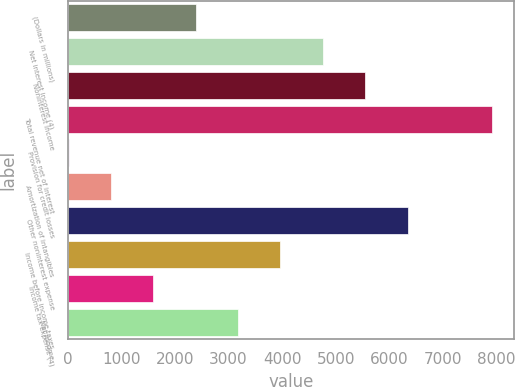Convert chart. <chart><loc_0><loc_0><loc_500><loc_500><bar_chart><fcel>(Dollars in millions)<fcel>Net interest income (4)<fcel>Noninterest income<fcel>Total revenue net of interest<fcel>Provision for credit losses<fcel>Amortization of intangibles<fcel>Other noninterest expense<fcel>Income before income taxes<fcel>Income tax expense (4)<fcel>Net income<nl><fcel>2386.7<fcel>4759.4<fcel>5550.3<fcel>7923<fcel>14<fcel>804.9<fcel>6341.2<fcel>3968.5<fcel>1595.8<fcel>3177.6<nl></chart> 